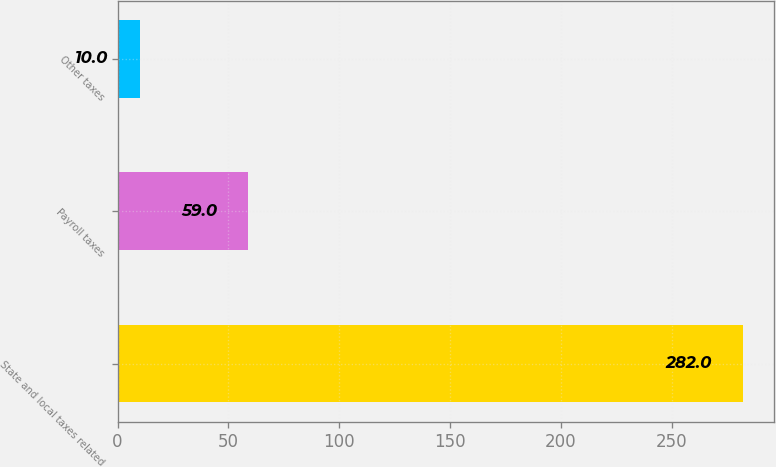Convert chart. <chart><loc_0><loc_0><loc_500><loc_500><bar_chart><fcel>State and local taxes related<fcel>Payroll taxes<fcel>Other taxes<nl><fcel>282<fcel>59<fcel>10<nl></chart> 